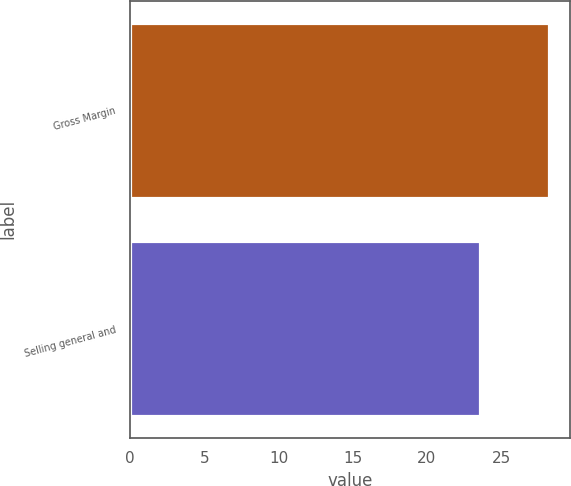Convert chart to OTSL. <chart><loc_0><loc_0><loc_500><loc_500><bar_chart><fcel>Gross Margin<fcel>Selling general and<nl><fcel>28.2<fcel>23.6<nl></chart> 